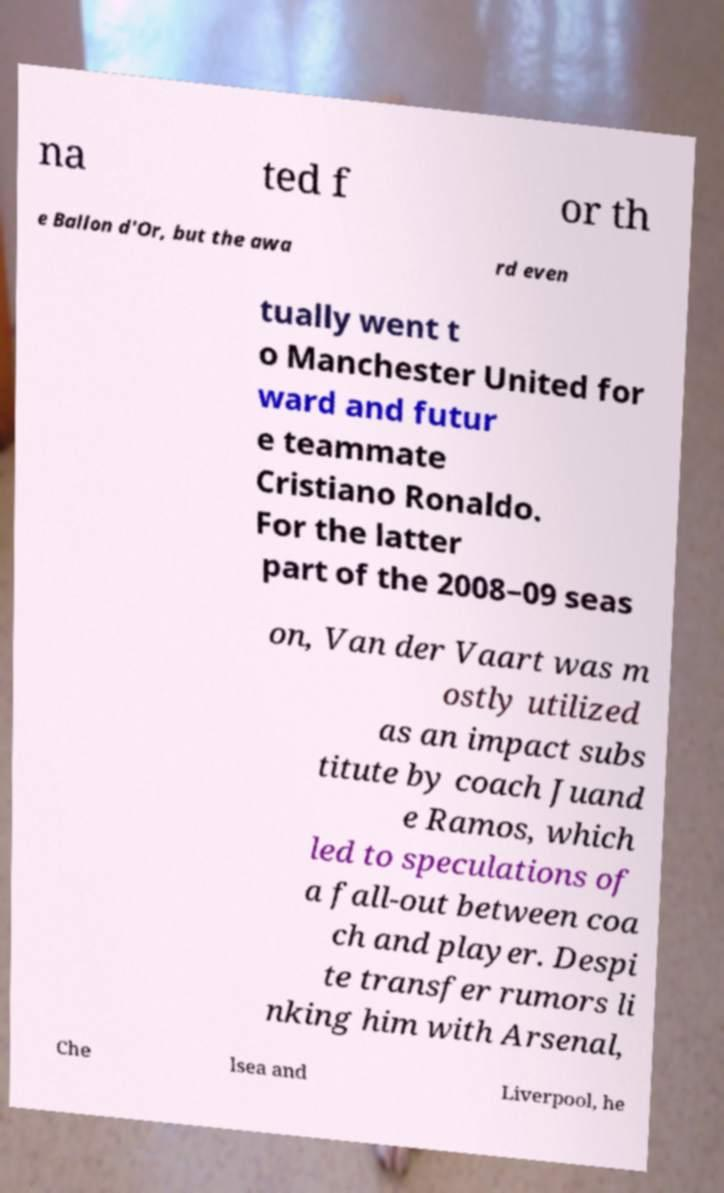There's text embedded in this image that I need extracted. Can you transcribe it verbatim? na ted f or th e Ballon d'Or, but the awa rd even tually went t o Manchester United for ward and futur e teammate Cristiano Ronaldo. For the latter part of the 2008–09 seas on, Van der Vaart was m ostly utilized as an impact subs titute by coach Juand e Ramos, which led to speculations of a fall-out between coa ch and player. Despi te transfer rumors li nking him with Arsenal, Che lsea and Liverpool, he 